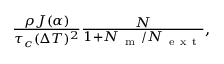<formula> <loc_0><loc_0><loc_500><loc_500>\begin{array} { r } { \frac { \rho J ( \alpha ) } { \tau _ { c } ( \Delta T ) ^ { 2 } } \frac { N } { 1 + N _ { m } / N _ { e x t } } , } \end{array}</formula> 